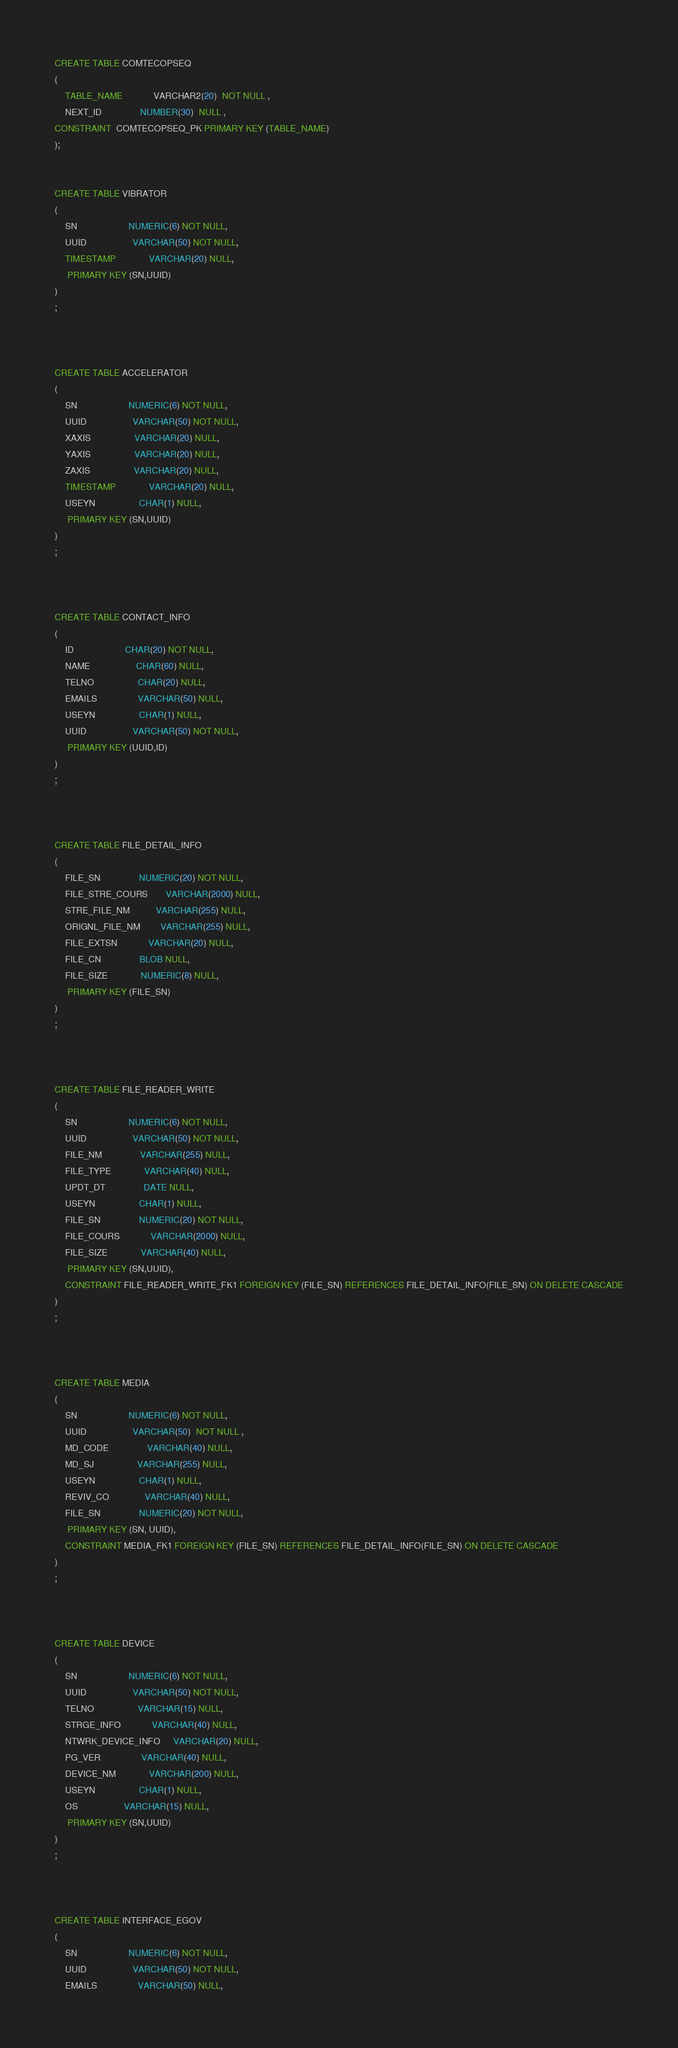Convert code to text. <code><loc_0><loc_0><loc_500><loc_500><_SQL_>CREATE TABLE COMTECOPSEQ
(
	TABLE_NAME            VARCHAR2(20)  NOT NULL ,
	NEXT_ID               NUMBER(30)  NULL ,
CONSTRAINT  COMTECOPSEQ_PK PRIMARY KEY (TABLE_NAME)
);


CREATE TABLE VIBRATOR
(
	SN                    NUMERIC(6) NOT NULL,
	UUID                  VARCHAR(50) NOT NULL,
	TIMESTAMP             VARCHAR(20) NULL,
	 PRIMARY KEY (SN,UUID)
)
;



CREATE TABLE ACCELERATOR
(
	SN                    NUMERIC(6) NOT NULL,
	UUID                  VARCHAR(50) NOT NULL,
	XAXIS                 VARCHAR(20) NULL,
	YAXIS                 VARCHAR(20) NULL,
	ZAXIS                 VARCHAR(20) NULL,
	TIMESTAMP             VARCHAR(20) NULL,
	USEYN                 CHAR(1) NULL,
	 PRIMARY KEY (SN,UUID)
)
;



CREATE TABLE CONTACT_INFO
(
	ID                    CHAR(20) NOT NULL,
	NAME                  CHAR(60) NULL,
	TELNO                 CHAR(20) NULL,
	EMAILS                VARCHAR(50) NULL,
	USEYN                 CHAR(1) NULL,
	UUID                  VARCHAR(50) NOT NULL,
	 PRIMARY KEY (UUID,ID)
)
;



CREATE TABLE FILE_DETAIL_INFO
(
	FILE_SN               NUMERIC(20) NOT NULL,
	FILE_STRE_COURS       VARCHAR(2000) NULL,
	STRE_FILE_NM          VARCHAR(255) NULL,
	ORIGNL_FILE_NM        VARCHAR(255) NULL,
	FILE_EXTSN            VARCHAR(20) NULL,
	FILE_CN               BLOB NULL,
	FILE_SIZE             NUMERIC(8) NULL,
	 PRIMARY KEY (FILE_SN)
)
;



CREATE TABLE FILE_READER_WRITE
(
	SN                    NUMERIC(6) NOT NULL,
	UUID                  VARCHAR(50) NOT NULL,
	FILE_NM               VARCHAR(255) NULL,
	FILE_TYPE             VARCHAR(40) NULL,
	UPDT_DT               DATE NULL,
	USEYN                 CHAR(1) NULL,
	FILE_SN               NUMERIC(20) NOT NULL,
	FILE_COURS            VARCHAR(2000) NULL,
	FILE_SIZE             VARCHAR(40) NULL,
	 PRIMARY KEY (SN,UUID),
	CONSTRAINT FILE_READER_WRITE_FK1 FOREIGN KEY (FILE_SN) REFERENCES FILE_DETAIL_INFO(FILE_SN) ON DELETE CASCADE
)
;



CREATE TABLE MEDIA
(
	SN                    NUMERIC(6) NOT NULL,
	UUID                  VARCHAR(50)  NOT NULL ,
	MD_CODE               VARCHAR(40) NULL,
	MD_SJ                 VARCHAR(255) NULL,
	USEYN                 CHAR(1) NULL,
	REVIV_CO              VARCHAR(40) NULL,
	FILE_SN               NUMERIC(20) NOT NULL,
	 PRIMARY KEY (SN, UUID),
	CONSTRAINT MEDIA_FK1 FOREIGN KEY (FILE_SN) REFERENCES FILE_DETAIL_INFO(FILE_SN) ON DELETE CASCADE
)
;



CREATE TABLE DEVICE
(
	SN                    NUMERIC(6) NOT NULL,
	UUID                  VARCHAR(50) NOT NULL,
	TELNO                 VARCHAR(15) NULL,
	STRGE_INFO            VARCHAR(40) NULL,
	NTWRK_DEVICE_INFO     VARCHAR(20) NULL,
	PG_VER                VARCHAR(40) NULL,
	DEVICE_NM             VARCHAR(200) NULL,
	USEYN                 CHAR(1) NULL,
	OS                  VARCHAR(15) NULL,
	 PRIMARY KEY (SN,UUID)
)
;



CREATE TABLE INTERFACE_EGOV
(
	SN                    NUMERIC(6) NOT NULL,
	UUID                  VARCHAR(50) NOT NULL,
	EMAILS                VARCHAR(50) NULL,</code> 